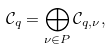Convert formula to latex. <formula><loc_0><loc_0><loc_500><loc_500>\mathcal { C } _ { q } = \bigoplus _ { \nu \in P } \mathcal { C } _ { q , \nu } ,</formula> 